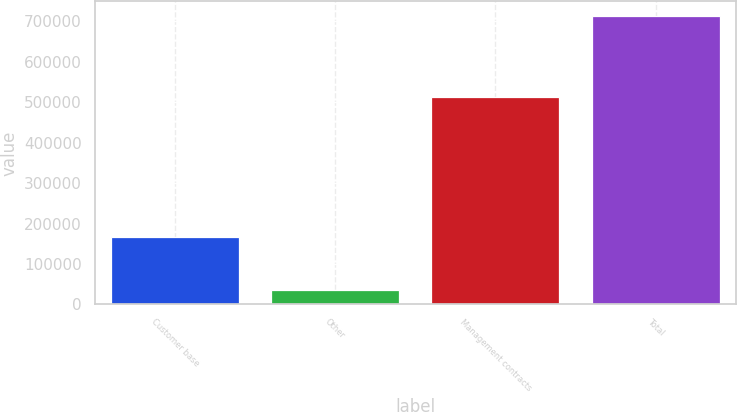<chart> <loc_0><loc_0><loc_500><loc_500><bar_chart><fcel>Customer base<fcel>Other<fcel>Management contracts<fcel>Total<nl><fcel>166212<fcel>35043<fcel>512456<fcel>713711<nl></chart> 